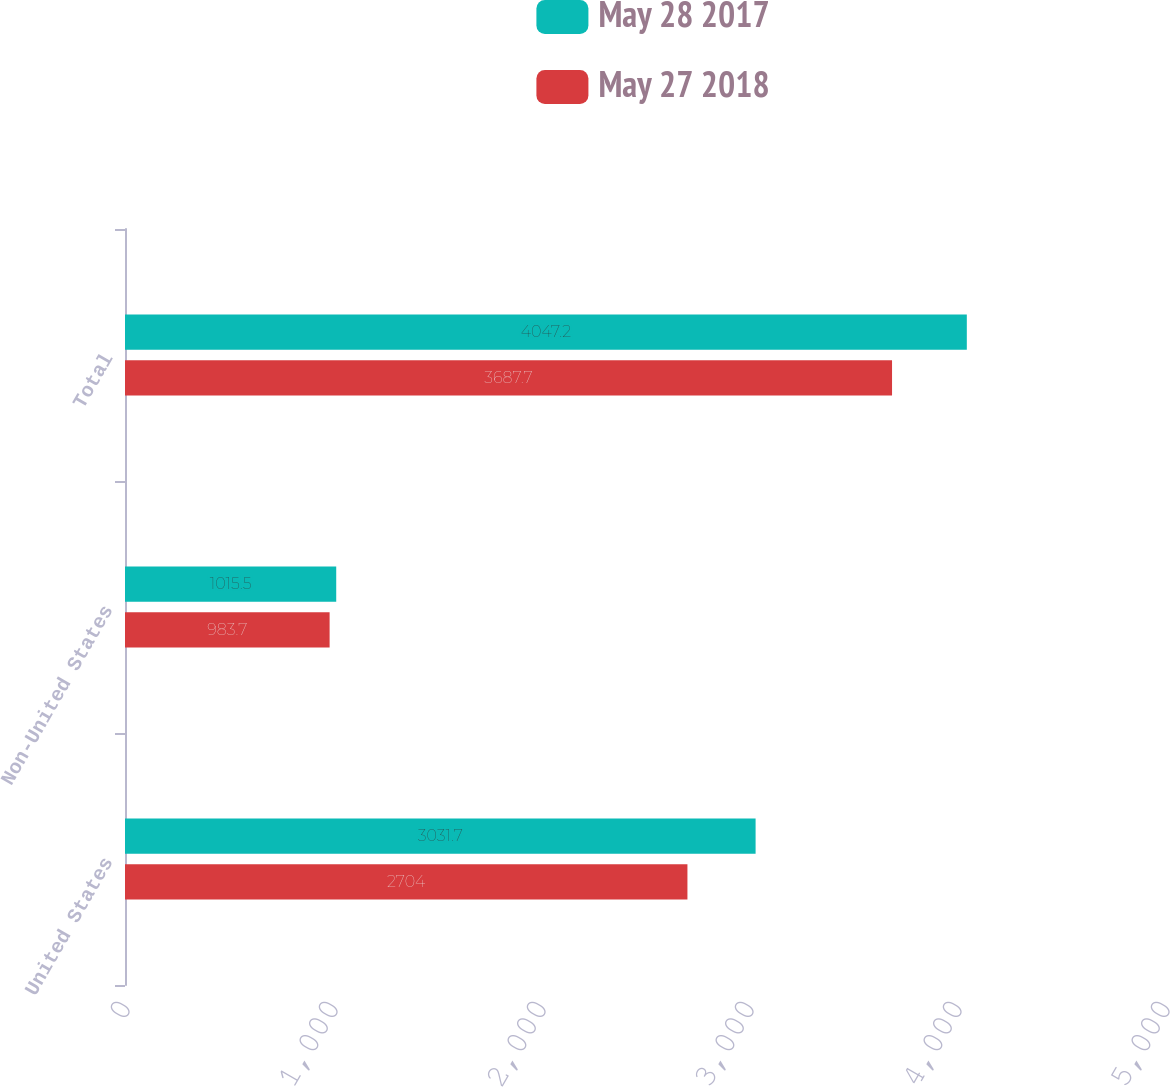Convert chart. <chart><loc_0><loc_0><loc_500><loc_500><stacked_bar_chart><ecel><fcel>United States<fcel>Non-United States<fcel>Total<nl><fcel>May 28 2017<fcel>3031.7<fcel>1015.5<fcel>4047.2<nl><fcel>May 27 2018<fcel>2704<fcel>983.7<fcel>3687.7<nl></chart> 